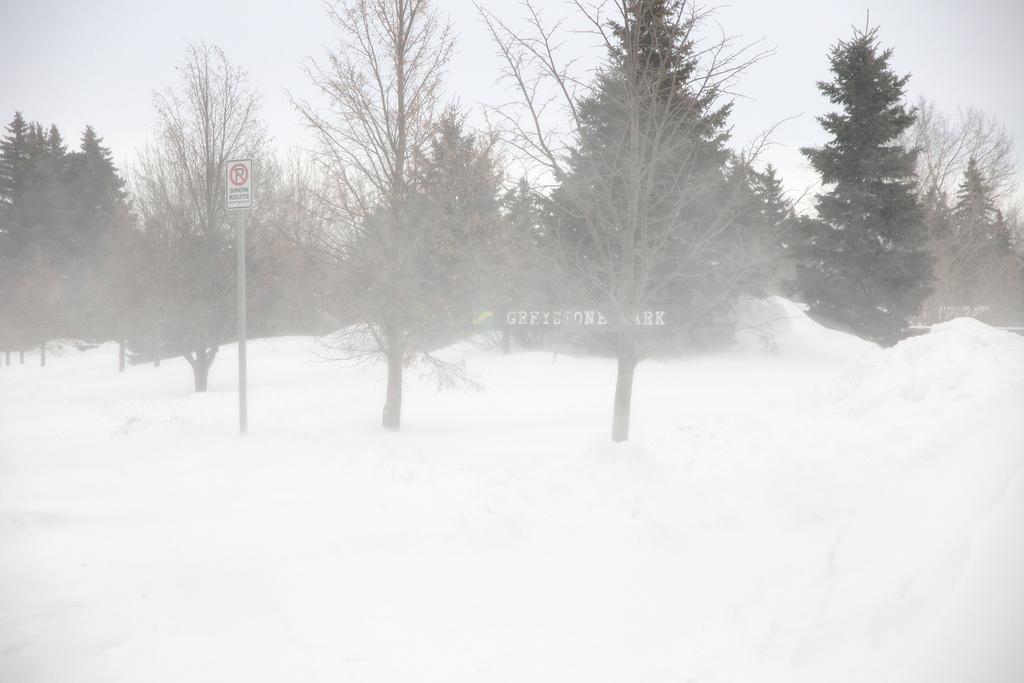Please provide a concise description of this image. In the foreground of this image, there is snow, a pole and trees. At the top, there is the sky. 